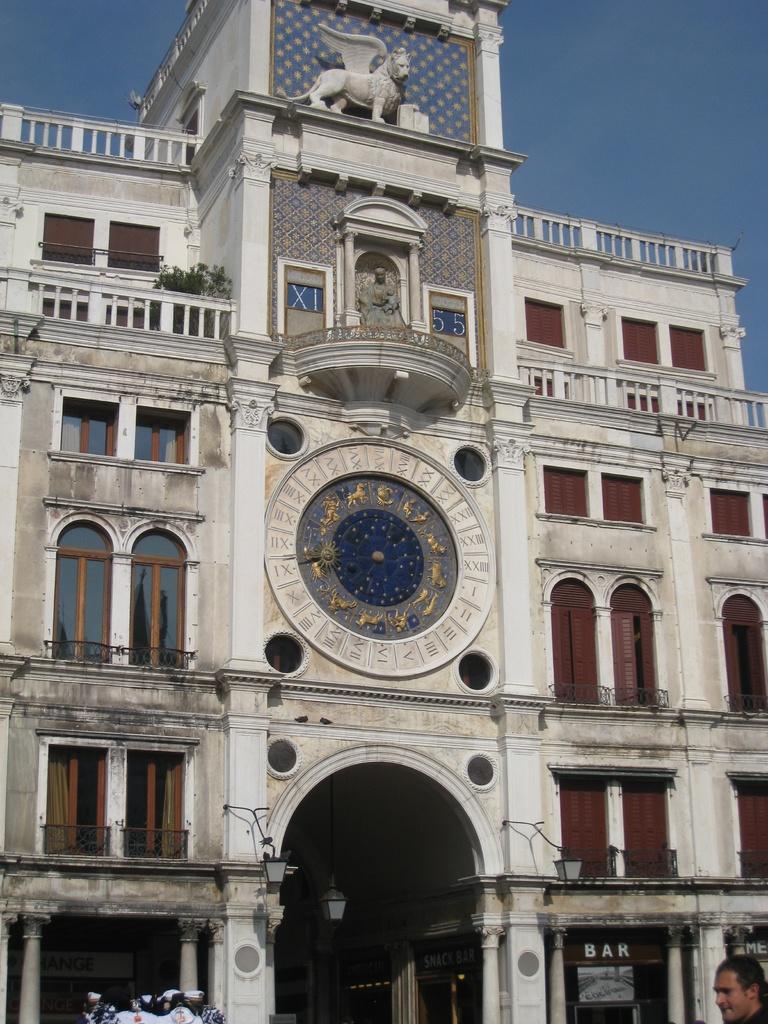Please provide a concise description of this image. In this image in the center there is a building, and at the bottom there is one person and also there are some windows and lights and some pillars. And at the top of the building there is a statue, and in the background there is sky. 